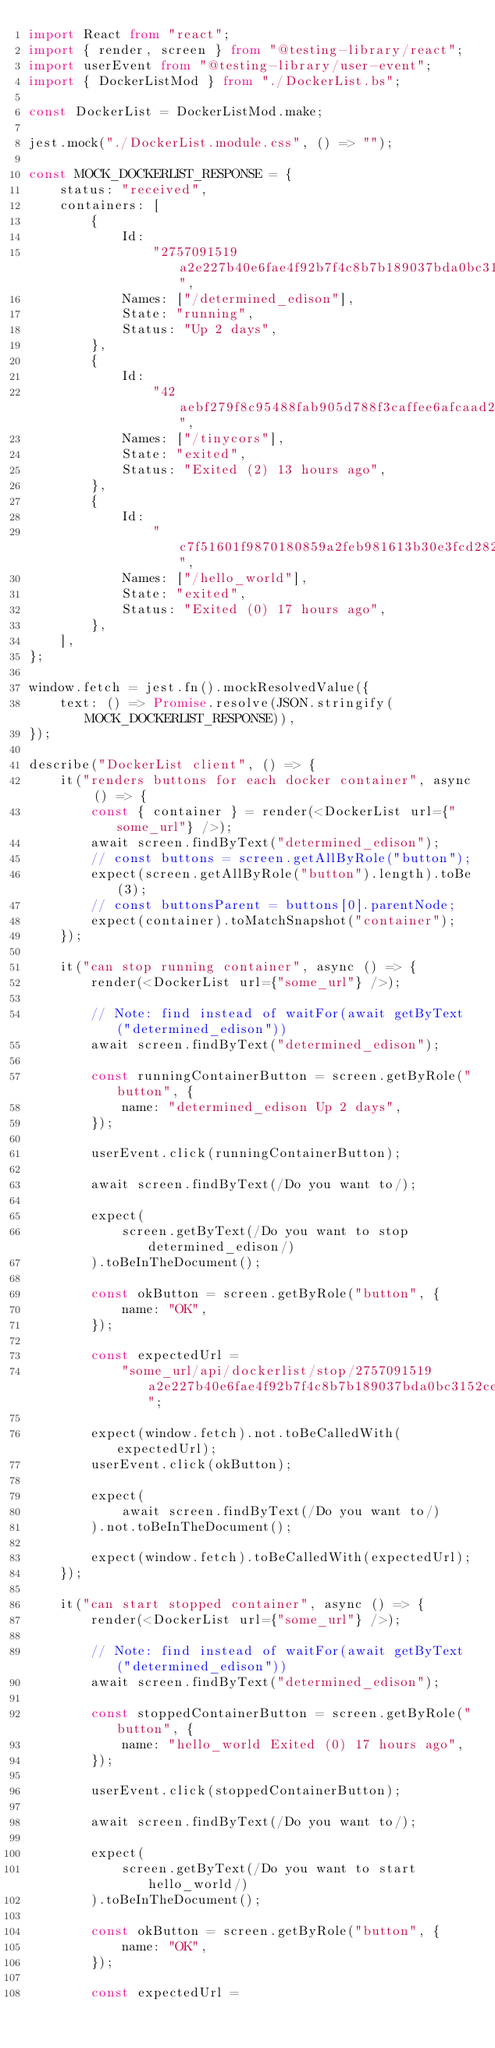Convert code to text. <code><loc_0><loc_0><loc_500><loc_500><_TypeScript_>import React from "react";
import { render, screen } from "@testing-library/react";
import userEvent from "@testing-library/user-event";
import { DockerListMod } from "./DockerList.bs";

const DockerList = DockerListMod.make;

jest.mock("./DockerList.module.css", () => "");

const MOCK_DOCKERLIST_RESPONSE = {
    status: "received",
    containers: [
        {
            Id:
                "2757091519a2e227b40e6fae4f92b7f4c8b7b189037bda0bc3152ce2be96af9d",
            Names: ["/determined_edison"],
            State: "running",
            Status: "Up 2 days",
        },
        {
            Id:
                "42aebf279f8c95488fab905d788f3caffee6afcaad240fc4aca68106c7173bfe",
            Names: ["/tinycors"],
            State: "exited",
            Status: "Exited (2) 13 hours ago",
        },
        {
            Id:
                "c7f51601f9870180859a2feb981613b30e3fcd282830b398185aa4facff21be1",
            Names: ["/hello_world"],
            State: "exited",
            Status: "Exited (0) 17 hours ago",
        },
    ],
};

window.fetch = jest.fn().mockResolvedValue({
    text: () => Promise.resolve(JSON.stringify(MOCK_DOCKERLIST_RESPONSE)),
});

describe("DockerList client", () => {
    it("renders buttons for each docker container", async () => {
        const { container } = render(<DockerList url={"some_url"} />);
        await screen.findByText("determined_edison");
        // const buttons = screen.getAllByRole("button");
        expect(screen.getAllByRole("button").length).toBe(3);
        // const buttonsParent = buttons[0].parentNode;
        expect(container).toMatchSnapshot("container");
    });

    it("can stop running container", async () => {
        render(<DockerList url={"some_url"} />);

        // Note: find instead of waitFor(await getByText("determined_edison"))
        await screen.findByText("determined_edison");

        const runningContainerButton = screen.getByRole("button", {
            name: "determined_edison Up 2 days",
        });

        userEvent.click(runningContainerButton);

        await screen.findByText(/Do you want to/);

        expect(
            screen.getByText(/Do you want to stop determined_edison/)
        ).toBeInTheDocument();

        const okButton = screen.getByRole("button", {
            name: "OK",
        });

        const expectedUrl =
            "some_url/api/dockerlist/stop/2757091519a2e227b40e6fae4f92b7f4c8b7b189037bda0bc3152ce2be96af9d";

        expect(window.fetch).not.toBeCalledWith(expectedUrl);
        userEvent.click(okButton);

        expect(
            await screen.findByText(/Do you want to/)
        ).not.toBeInTheDocument();

        expect(window.fetch).toBeCalledWith(expectedUrl);
    });

    it("can start stopped container", async () => {
        render(<DockerList url={"some_url"} />);

        // Note: find instead of waitFor(await getByText("determined_edison"))
        await screen.findByText("determined_edison");

        const stoppedContainerButton = screen.getByRole("button", {
            name: "hello_world Exited (0) 17 hours ago",
        });

        userEvent.click(stoppedContainerButton);

        await screen.findByText(/Do you want to/);

        expect(
            screen.getByText(/Do you want to start hello_world/)
        ).toBeInTheDocument();

        const okButton = screen.getByRole("button", {
            name: "OK",
        });

        const expectedUrl =</code> 